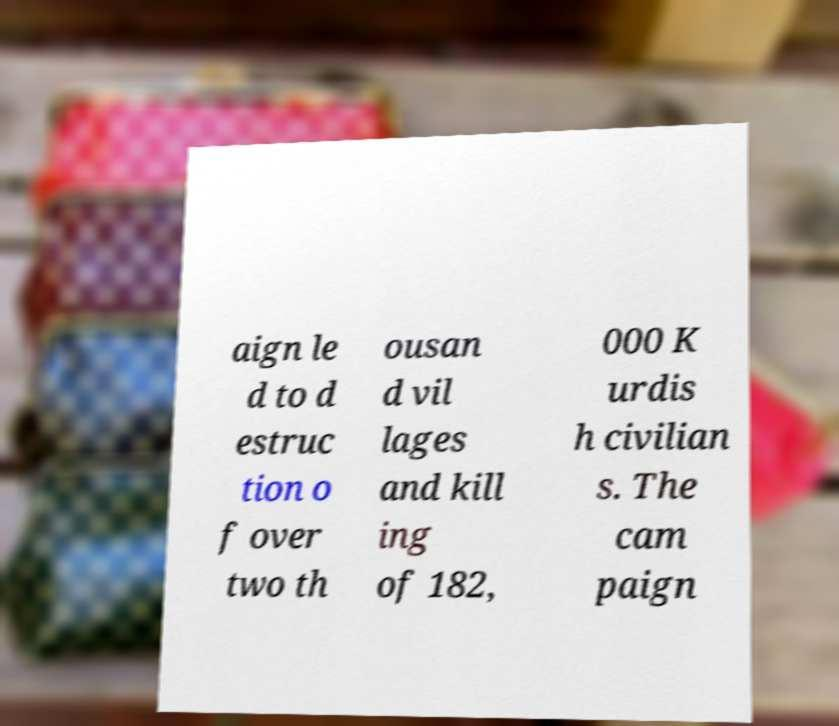Could you extract and type out the text from this image? aign le d to d estruc tion o f over two th ousan d vil lages and kill ing of 182, 000 K urdis h civilian s. The cam paign 